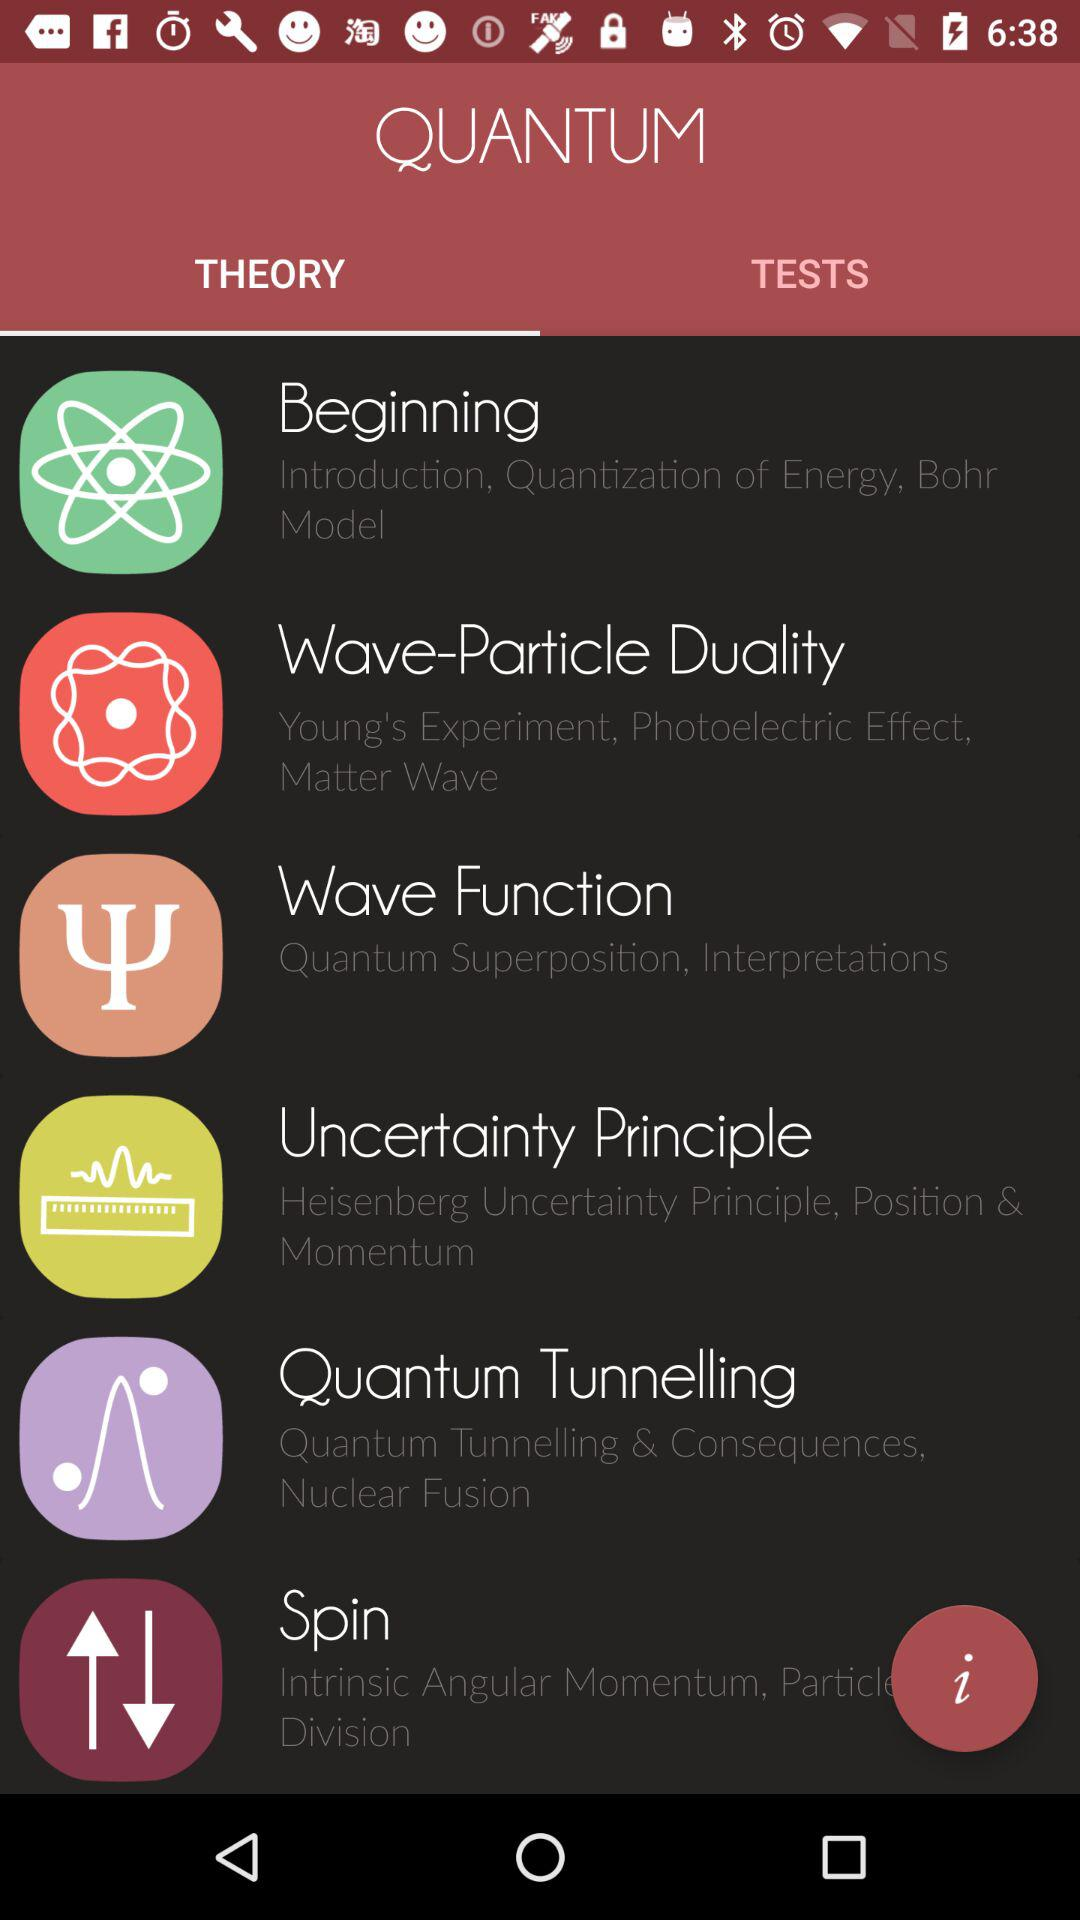Name the given quantum theories? The given quantum theories are "Beginning", "Wave-Particle Duality", "Wave Function", "Uncertainty Principle", "Quantum Tunnelling" and "Spin". 